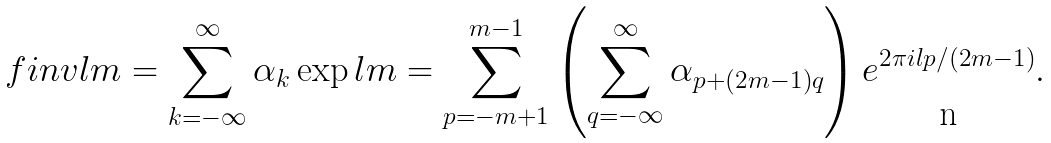<formula> <loc_0><loc_0><loc_500><loc_500>\ f i n v l m = \sum _ { k = - \infty } ^ { \infty } \alpha _ { k } \exp l m = \sum _ { p = - m + 1 } ^ { m - 1 } \left ( \sum _ { q = - \infty } ^ { \infty } \alpha _ { p + ( 2 m - 1 ) q } \right ) e ^ { 2 \pi i l p / ( 2 m - 1 ) } .</formula> 